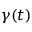Convert formula to latex. <formula><loc_0><loc_0><loc_500><loc_500>\gamma ( t )</formula> 